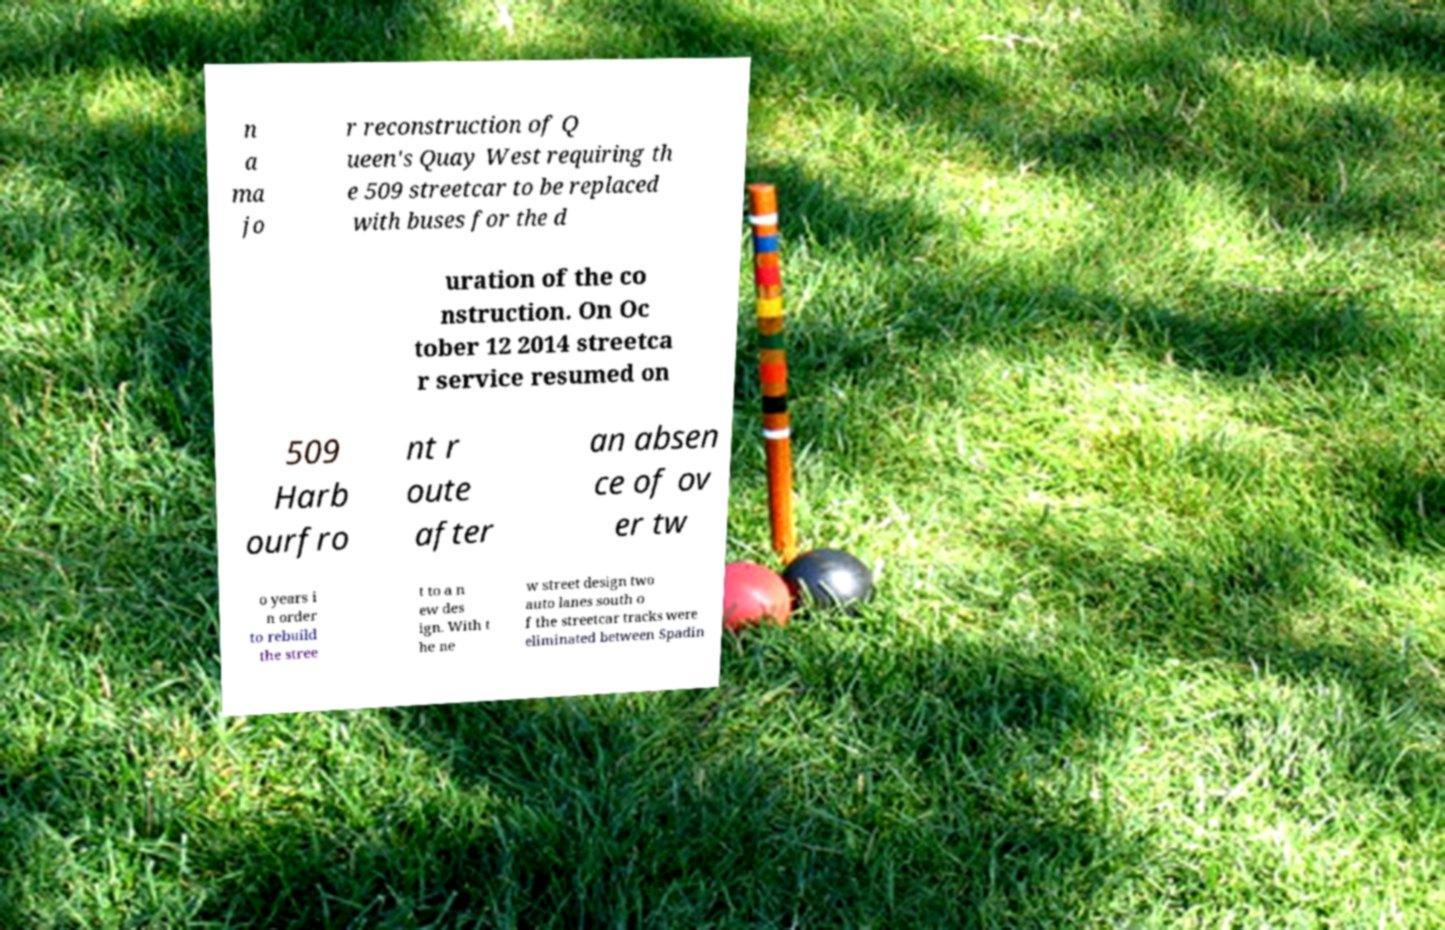Please read and relay the text visible in this image. What does it say? n a ma jo r reconstruction of Q ueen's Quay West requiring th e 509 streetcar to be replaced with buses for the d uration of the co nstruction. On Oc tober 12 2014 streetca r service resumed on 509 Harb ourfro nt r oute after an absen ce of ov er tw o years i n order to rebuild the stree t to a n ew des ign. With t he ne w street design two auto lanes south o f the streetcar tracks were eliminated between Spadin 